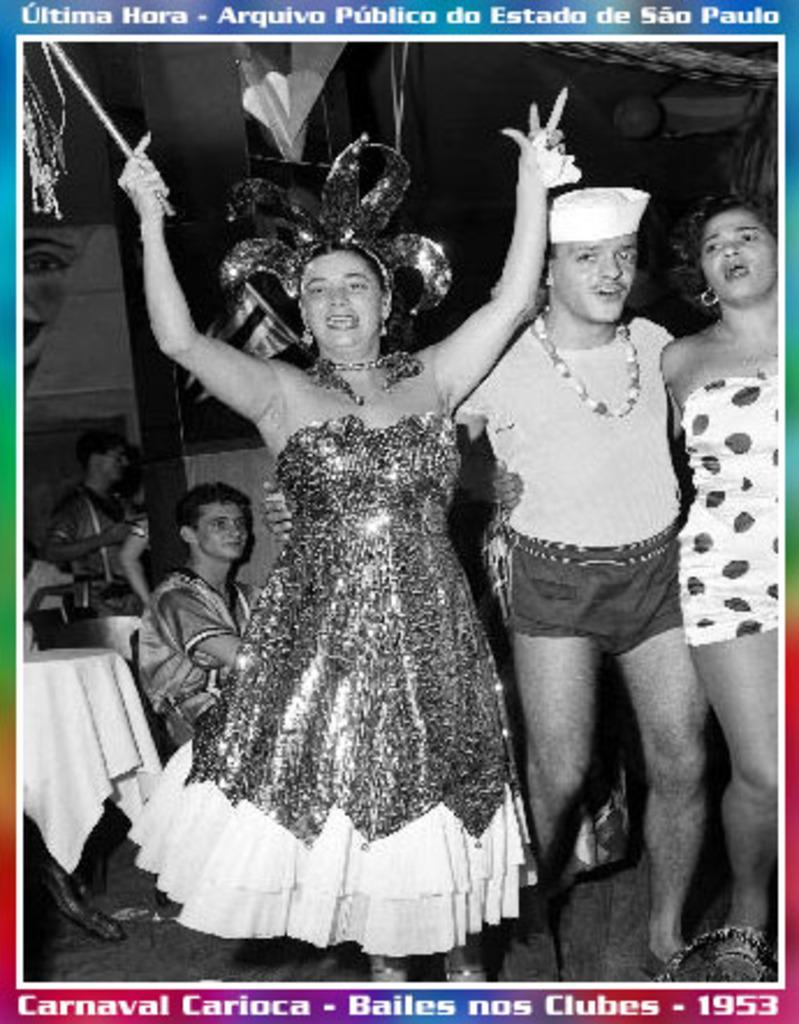Please provide a concise description of this image. This picture is a poster. It is in black and white. In this picture, we see three people are standing. I think they are singing the songs and dancing. Behind them, we see people sitting on the chairs and behind them, we see the tables. In the background, we see a wall graffiti. In the background, it is black in color. 